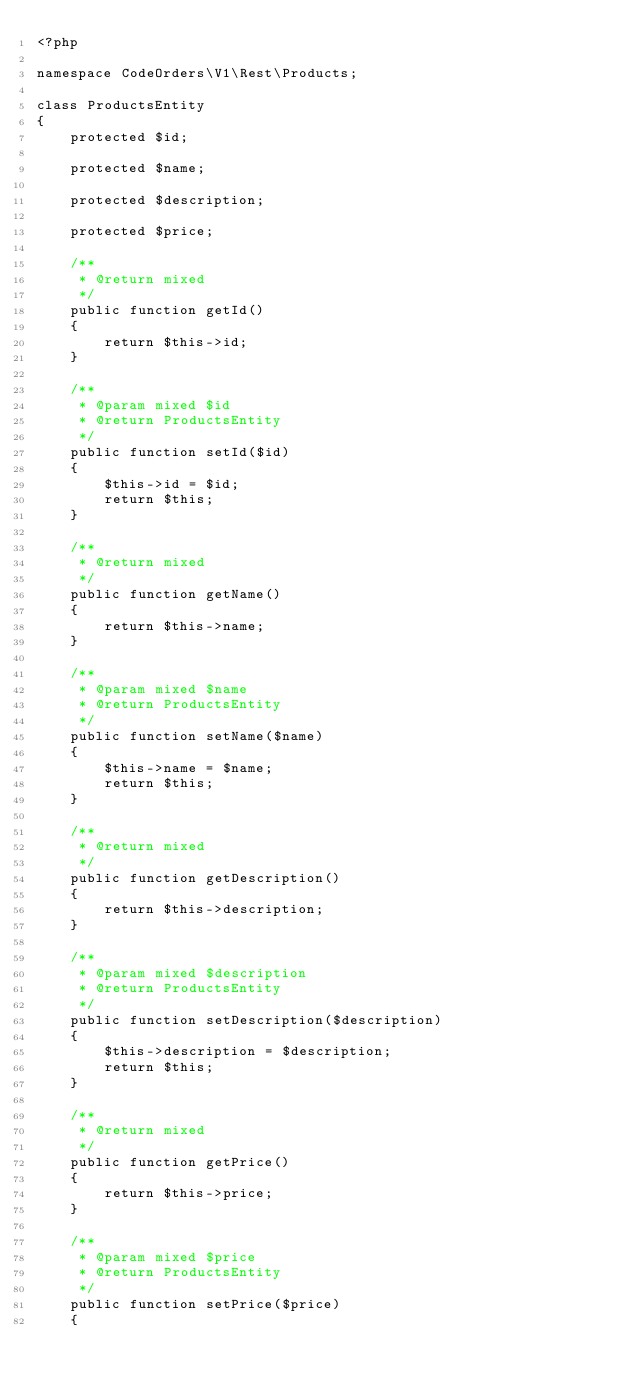<code> <loc_0><loc_0><loc_500><loc_500><_PHP_><?php

namespace CodeOrders\V1\Rest\Products;

class ProductsEntity
{
    protected $id;

    protected $name;

    protected $description;

    protected $price;

    /**
     * @return mixed
     */
    public function getId()
    {
        return $this->id;
    }

    /**
     * @param mixed $id
     * @return ProductsEntity
     */
    public function setId($id)
    {
        $this->id = $id;
        return $this;
    }

    /**
     * @return mixed
     */
    public function getName()
    {
        return $this->name;
    }

    /**
     * @param mixed $name
     * @return ProductsEntity
     */
    public function setName($name)
    {
        $this->name = $name;
        return $this;
    }

    /**
     * @return mixed
     */
    public function getDescription()
    {
        return $this->description;
    }

    /**
     * @param mixed $description
     * @return ProductsEntity
     */
    public function setDescription($description)
    {
        $this->description = $description;
        return $this;
    }

    /**
     * @return mixed
     */
    public function getPrice()
    {
        return $this->price;
    }

    /**
     * @param mixed $price
     * @return ProductsEntity
     */
    public function setPrice($price)
    {</code> 